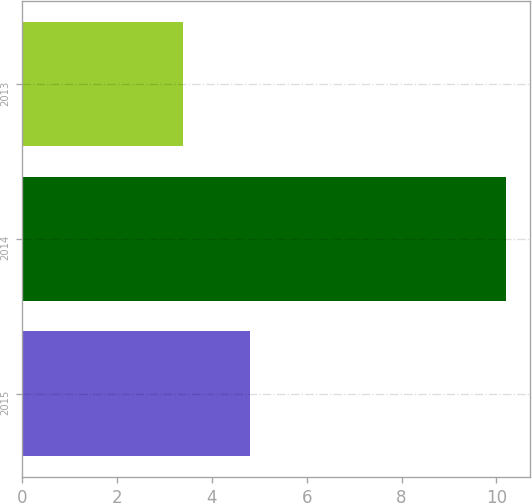Convert chart to OTSL. <chart><loc_0><loc_0><loc_500><loc_500><bar_chart><fcel>2015<fcel>2014<fcel>2013<nl><fcel>4.8<fcel>10.2<fcel>3.4<nl></chart> 